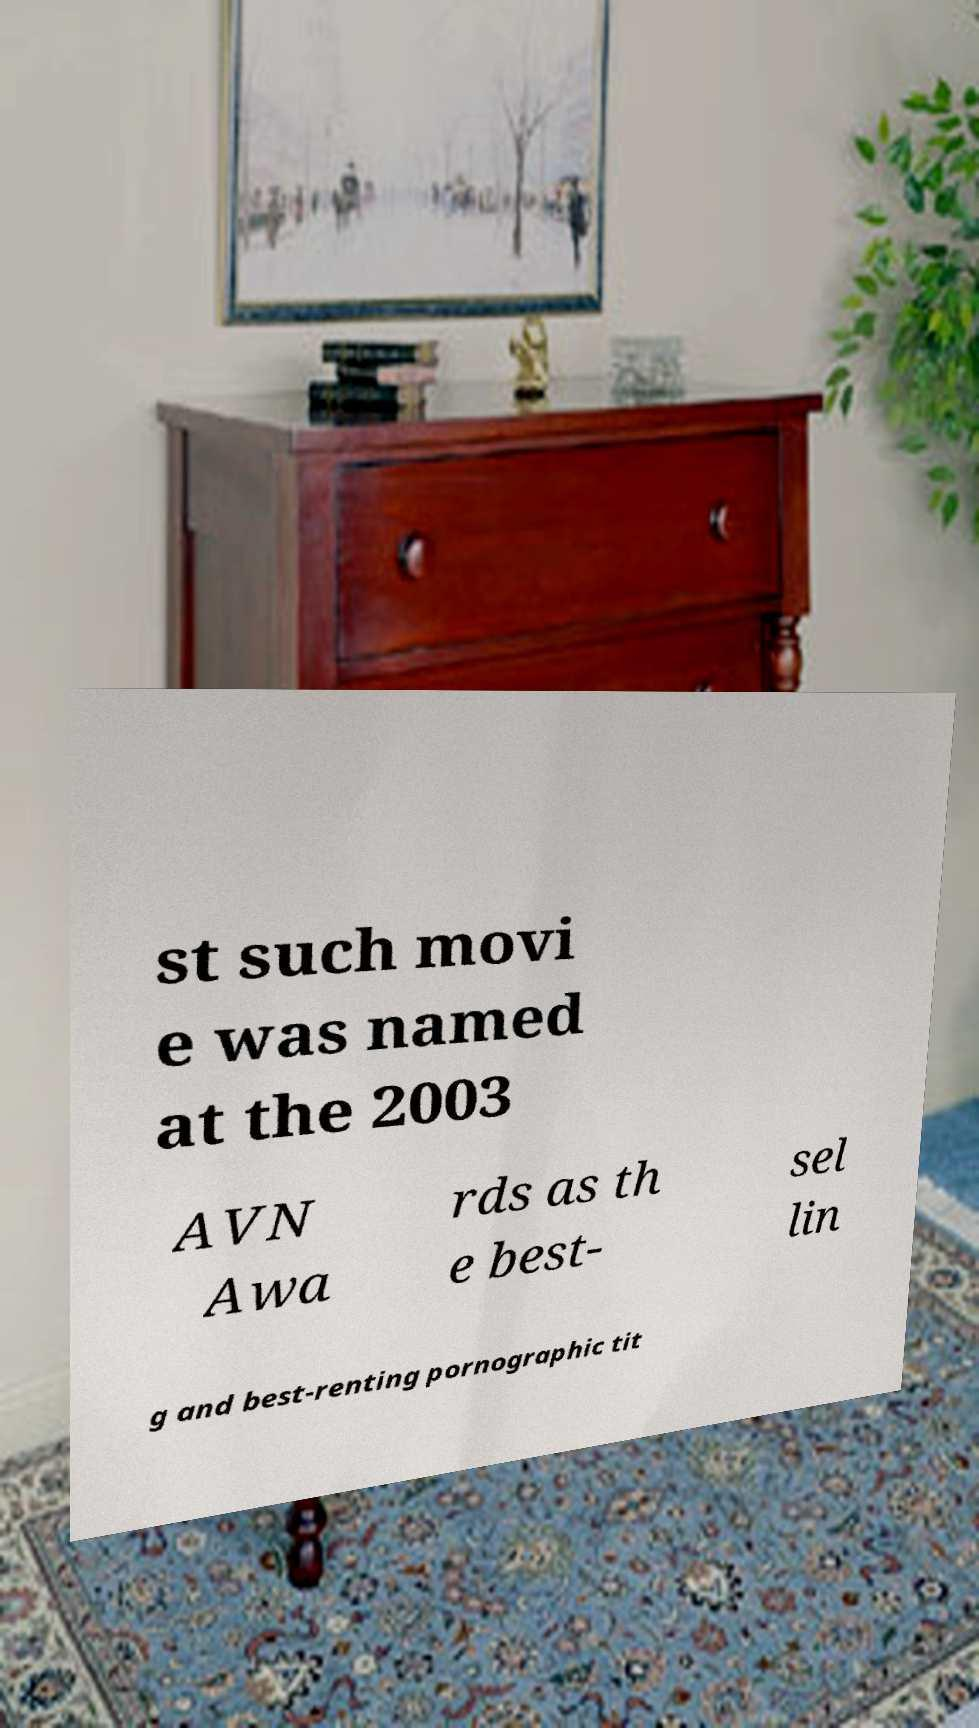Can you accurately transcribe the text from the provided image for me? st such movi e was named at the 2003 AVN Awa rds as th e best- sel lin g and best-renting pornographic tit 